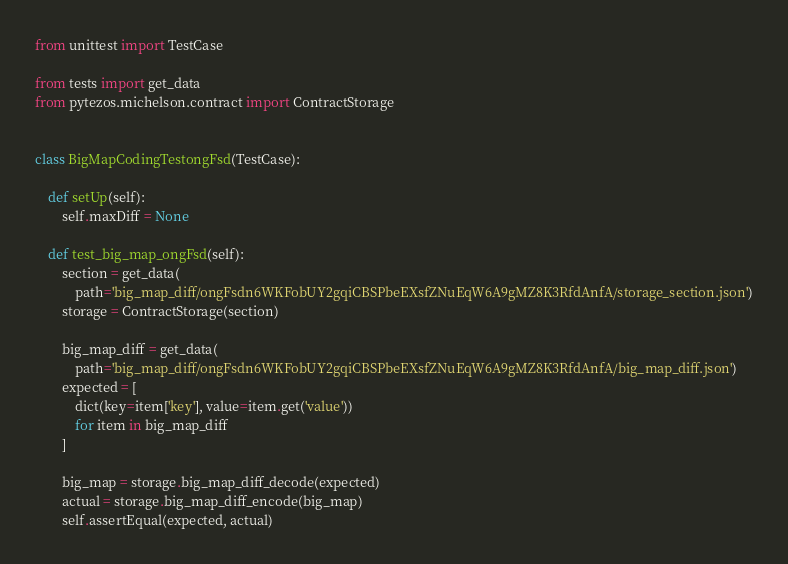<code> <loc_0><loc_0><loc_500><loc_500><_Python_>from unittest import TestCase

from tests import get_data
from pytezos.michelson.contract import ContractStorage


class BigMapCodingTestongFsd(TestCase):

    def setUp(self):
        self.maxDiff = None

    def test_big_map_ongFsd(self):    
        section = get_data(
            path='big_map_diff/ongFsdn6WKFobUY2gqiCBSPbeEXsfZNuEqW6A9gMZ8K3RfdAnfA/storage_section.json')
        storage = ContractStorage(section)
            
        big_map_diff = get_data(
            path='big_map_diff/ongFsdn6WKFobUY2gqiCBSPbeEXsfZNuEqW6A9gMZ8K3RfdAnfA/big_map_diff.json')
        expected = [
            dict(key=item['key'], value=item.get('value'))
            for item in big_map_diff
        ]
        
        big_map = storage.big_map_diff_decode(expected)
        actual = storage.big_map_diff_encode(big_map)
        self.assertEqual(expected, actual)
</code> 